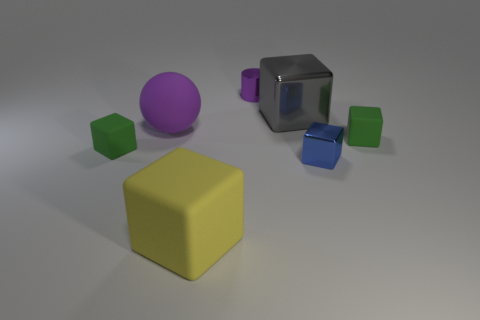There is a green object that is right of the purple sphere; how big is it?
Make the answer very short. Small. Do the gray shiny object and the purple rubber sphere have the same size?
Keep it short and to the point. Yes. How many rubber blocks are both to the right of the ball and behind the yellow matte cube?
Offer a terse response. 1. What number of purple objects are either cubes or shiny blocks?
Offer a very short reply. 0. How many rubber objects are cylinders or green cubes?
Keep it short and to the point. 2. Are any tiny things visible?
Make the answer very short. Yes. Is the shape of the gray metal object the same as the small purple thing?
Provide a succinct answer. No. How many tiny green cubes are to the right of the metal thing behind the gray shiny block that is right of the small purple object?
Offer a very short reply. 1. There is a tiny thing that is both on the right side of the big purple sphere and left of the blue metal cube; what is its material?
Provide a short and direct response. Metal. The metal thing that is behind the blue metal cube and in front of the tiny purple object is what color?
Your answer should be compact. Gray. 